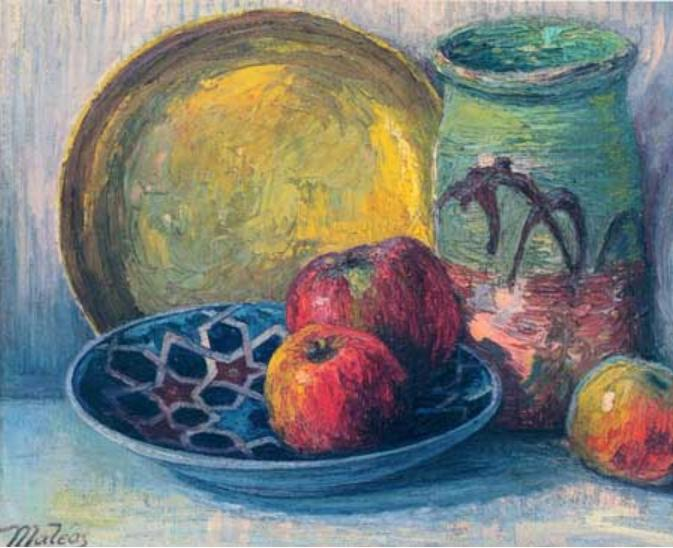What emotions or mood does this painting evoke? The painting evokes a sense of tranquility and simplicity, typical of impressionist still lifes. The warm tones of the yellow plate juxtaposed with the cooler hues of the blue bowl create a harmonious balance, while the vibrantly colored apples add a lively touch. The loose brushstrokes suggest a relaxed and informal setting, promoting a feeling of calmness and a gentle appreciation for the everyday beauty found in simple objects. 